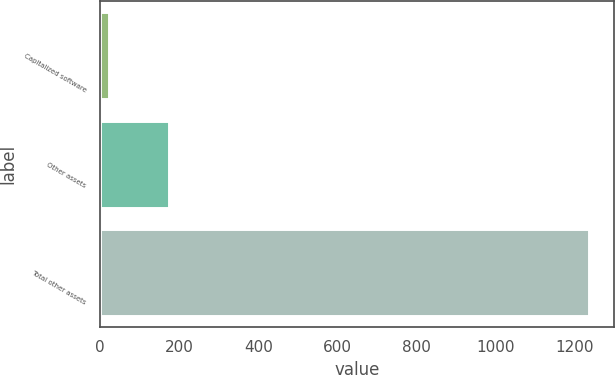<chart> <loc_0><loc_0><loc_500><loc_500><bar_chart><fcel>Capitalized software<fcel>Other assets<fcel>Total other assets<nl><fcel>21<fcel>175<fcel>1238<nl></chart> 